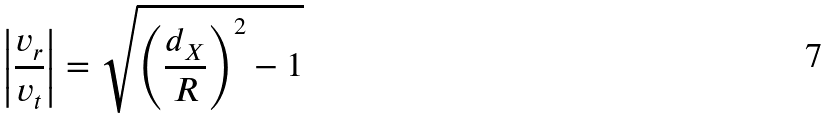<formula> <loc_0><loc_0><loc_500><loc_500>\left | \frac { v _ { r } } { v _ { t } } \right | = \sqrt { \left ( \frac { d _ { X } } { R } \right ) ^ { 2 } - 1 }</formula> 